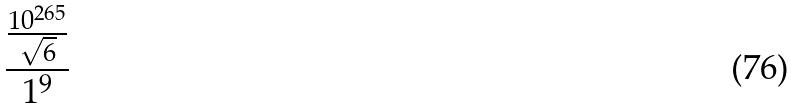Convert formula to latex. <formula><loc_0><loc_0><loc_500><loc_500>\frac { \frac { 1 0 ^ { 2 6 5 } } { \sqrt { 6 } } } { 1 ^ { 9 } }</formula> 